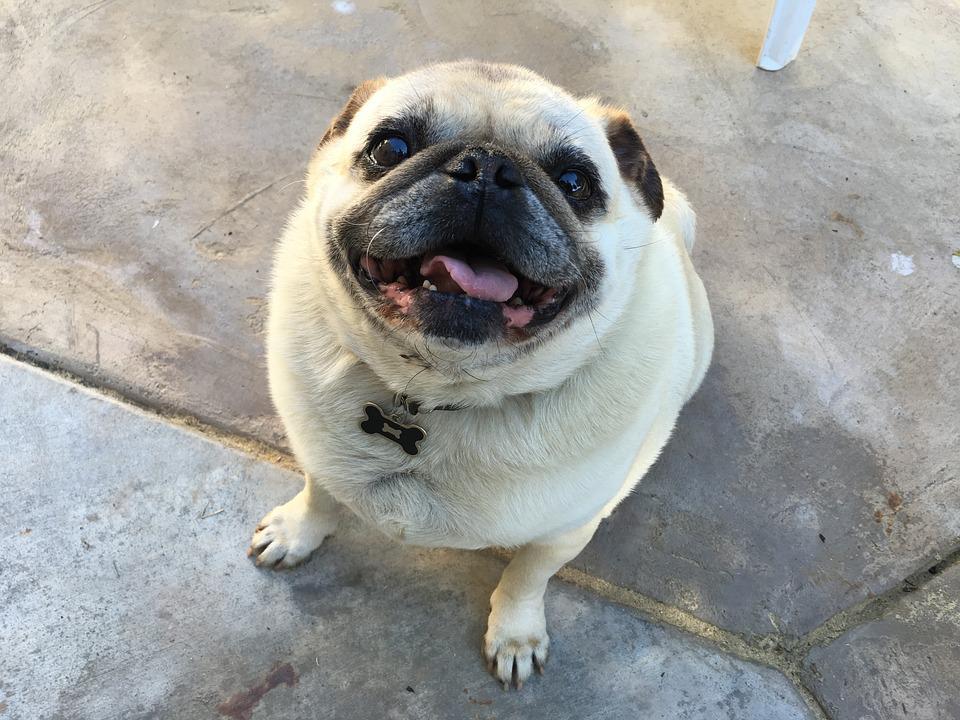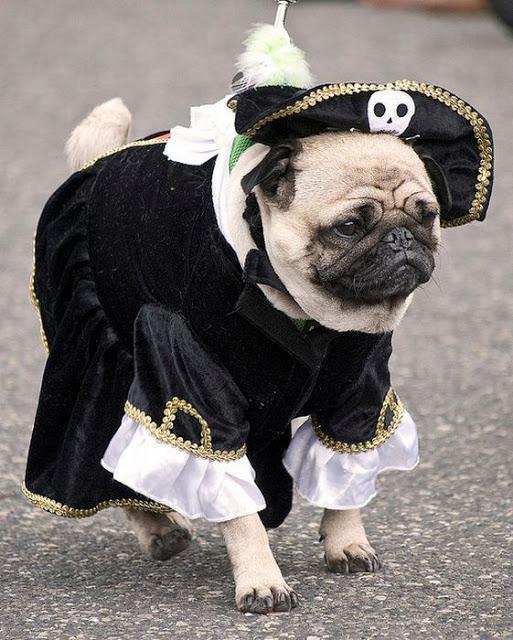The first image is the image on the left, the second image is the image on the right. Considering the images on both sides, is "There is only one dog in each of the images." valid? Answer yes or no. Yes. The first image is the image on the left, the second image is the image on the right. Examine the images to the left and right. Is the description "The right image contains one black pug and a human hand, and no image contains a standing dog." accurate? Answer yes or no. No. 